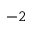<formula> <loc_0><loc_0><loc_500><loc_500>^ { - 2 }</formula> 